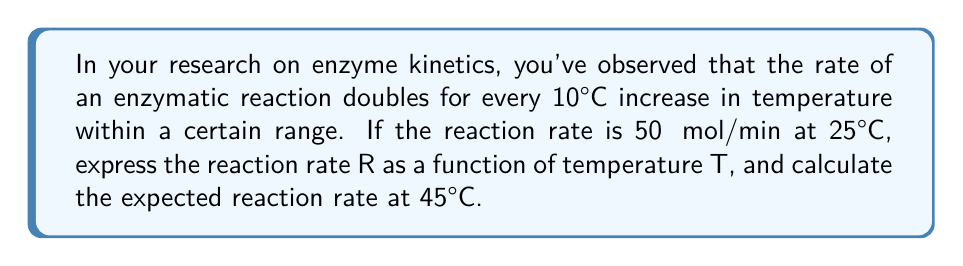Solve this math problem. Let's approach this step-by-step:

1) We're dealing with exponential growth, as the rate doubles for every 10°C increase. The general form of such a function is:

   $$R(T) = R_0 \cdot a^{\frac{T-T_0}{10}}$$

   Where $R_0$ is the initial rate, $T_0$ is the initial temperature, and $a$ is the growth factor.

2) We know that:
   - $R_0 = 50$ μmol/min
   - $T_0 = 25°C$
   - The rate doubles every 10°C, so $a = 2$

3) Substituting these values into our equation:

   $$R(T) = 50 \cdot 2^{\frac{T-25}{10}}$$

4) To find the rate at 45°C, we substitute $T = 45$ into our function:

   $$R(45) = 50 \cdot 2^{\frac{45-25}{10}} = 50 \cdot 2^2 = 50 \cdot 4 = 200$$

5) Therefore, at 45°C, the reaction rate is expected to be 200 μmol/min.
Answer: The reaction rate as a function of temperature is $R(T) = 50 \cdot 2^{\frac{T-25}{10}}$ μmol/min, where $T$ is in °C. At 45°C, the expected reaction rate is 200 μmol/min. 